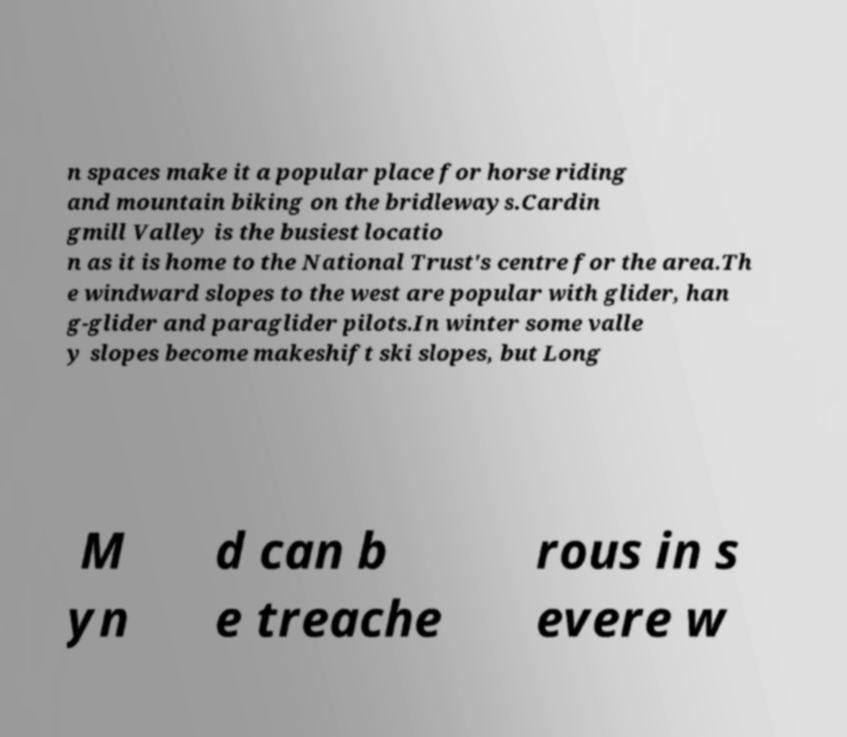I need the written content from this picture converted into text. Can you do that? n spaces make it a popular place for horse riding and mountain biking on the bridleways.Cardin gmill Valley is the busiest locatio n as it is home to the National Trust's centre for the area.Th e windward slopes to the west are popular with glider, han g-glider and paraglider pilots.In winter some valle y slopes become makeshift ski slopes, but Long M yn d can b e treache rous in s evere w 